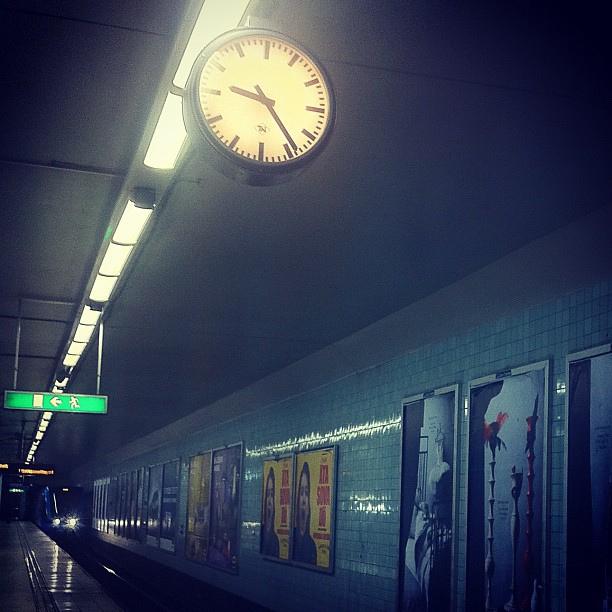What time is it on the clock?
Give a very brief answer. 9:24. Is this underground?
Concise answer only. Yes. Is this clock still working?
Answer briefly. Yes. 